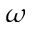Convert formula to latex. <formula><loc_0><loc_0><loc_500><loc_500>\omega</formula> 